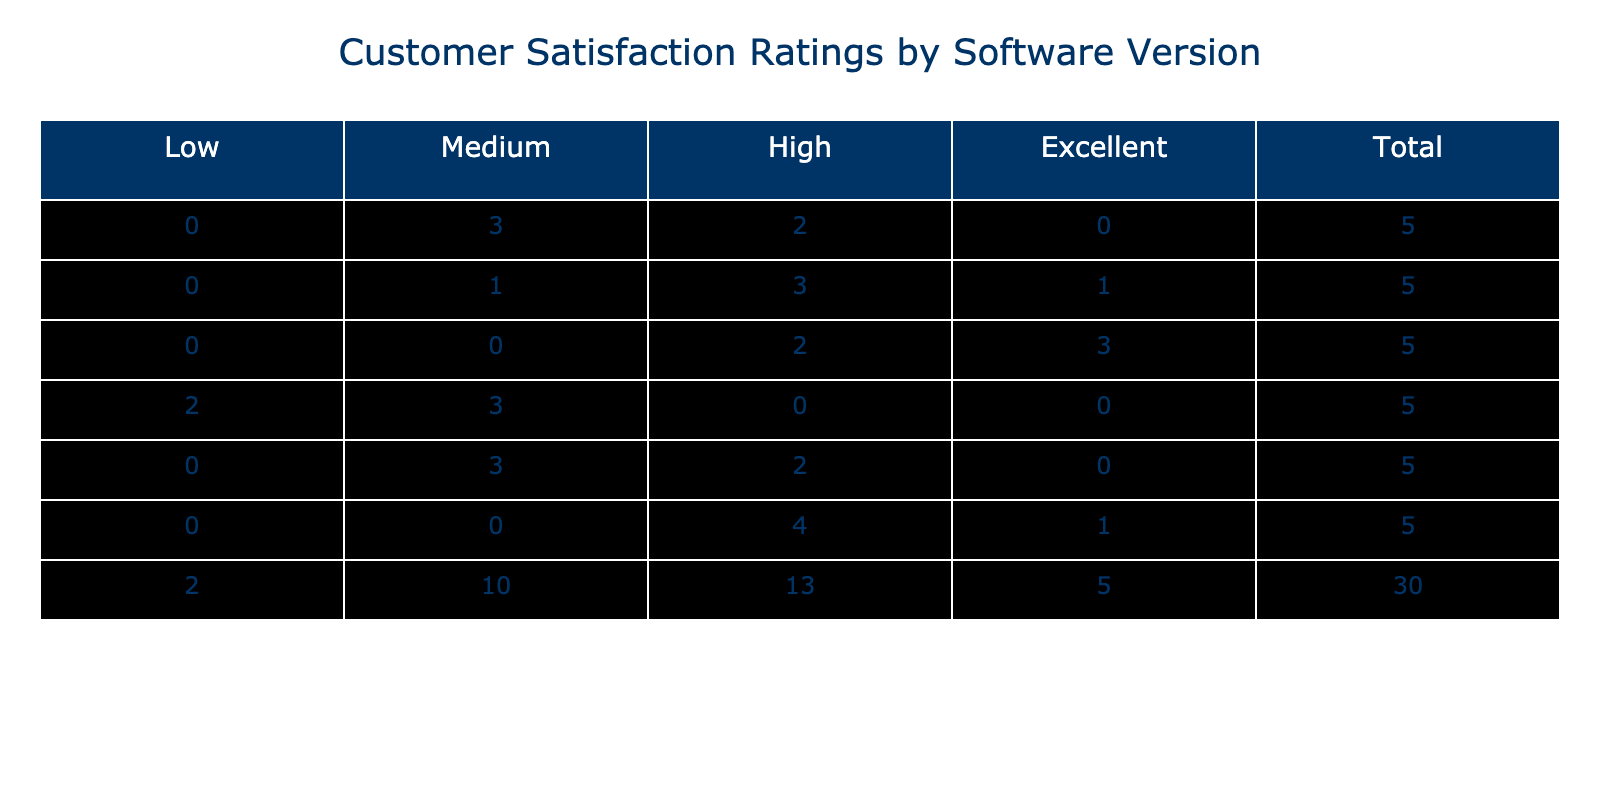What is the total number of customers who rated the software? To find the total number of customers, we look at the last column of the contingency table, which shows the total for each software version. We then sum these totals: 5 (Version 1.0) + 5 (Version 1.1) + 5 (Version 1.2) + 5 (Version 2.0) + 5 (Version 2.1) + 5 (Version 2.2) = 30.
Answer: 30 Which software version received the highest number of 'Excellent' ratings? By checking the 'Excellent' row in the table, we can see that Version 1.2 has 5 ratings categorized as 'Excellent', which is the highest compared to other software versions.
Answer: Version 1.2 What is the average customer satisfaction rating for Version 2.0? For Version 2.0, the ratings are 76, 70, 72, 68, 74. Adding these gives us 360. To find the average, we divide by the number of ratings (5): 360 / 5 = 72.
Answer: 72 Is Version 1.1 rated higher on average than Version 2.1? The average for Version 1.1 is calculated by summing the ratings (88 + 79 + 92 + 84 + 87 = 430) and dividing by 5, which gives 86. The average for Version 2.1 is (82 + 79 + 80 + 81 + 78 = 400), which gives 80. Since 86 is greater than 80, we conclude that Version 1.1 is rated higher.
Answer: Yes How many customers rated Version 2.2, and what percentage of these rated it as 'High'? Version 2.2 has 5 customers (checked through the totals), and 3 of these rated it as 'High'. To determine the percentage, we calculate (3/5) * 100 = 60%.
Answer: 60% 